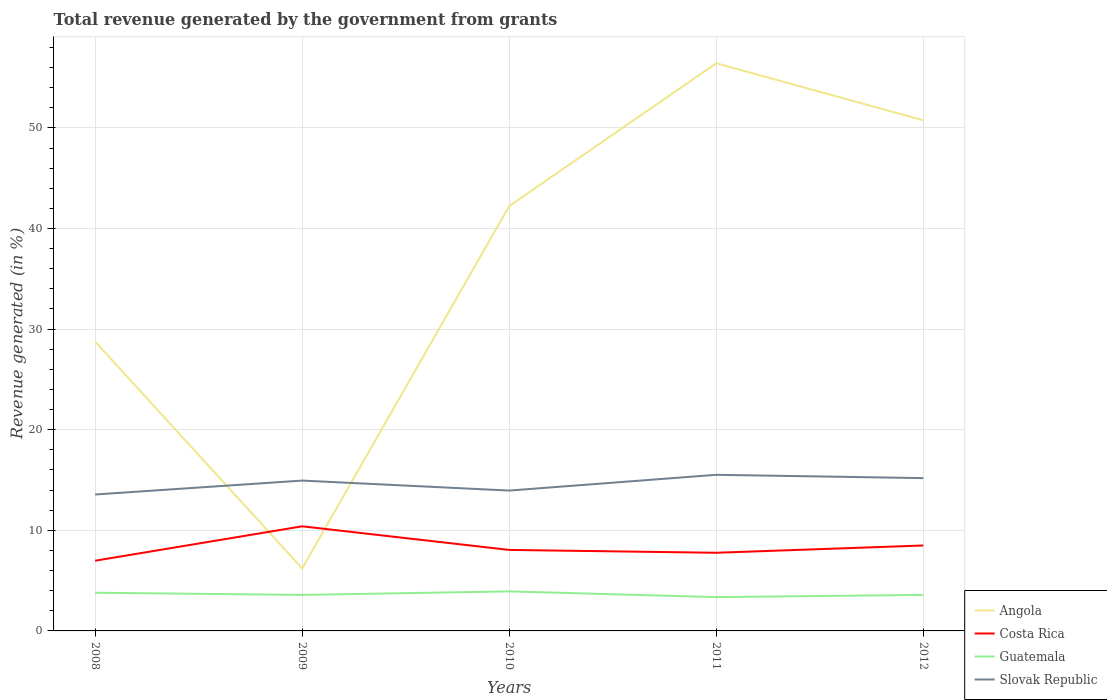How many different coloured lines are there?
Give a very brief answer. 4. Across all years, what is the maximum total revenue generated in Costa Rica?
Offer a terse response. 6.98. What is the total total revenue generated in Slovak Republic in the graph?
Give a very brief answer. -1.24. What is the difference between the highest and the second highest total revenue generated in Angola?
Make the answer very short. 50.21. What is the difference between the highest and the lowest total revenue generated in Angola?
Provide a short and direct response. 3. Is the total revenue generated in Guatemala strictly greater than the total revenue generated in Costa Rica over the years?
Keep it short and to the point. Yes. How many lines are there?
Provide a short and direct response. 4. Does the graph contain any zero values?
Offer a terse response. No. How are the legend labels stacked?
Offer a very short reply. Vertical. What is the title of the graph?
Your answer should be compact. Total revenue generated by the government from grants. What is the label or title of the X-axis?
Your response must be concise. Years. What is the label or title of the Y-axis?
Make the answer very short. Revenue generated (in %). What is the Revenue generated (in %) of Angola in 2008?
Ensure brevity in your answer.  28.76. What is the Revenue generated (in %) in Costa Rica in 2008?
Provide a short and direct response. 6.98. What is the Revenue generated (in %) of Guatemala in 2008?
Ensure brevity in your answer.  3.8. What is the Revenue generated (in %) of Slovak Republic in 2008?
Keep it short and to the point. 13.56. What is the Revenue generated (in %) of Angola in 2009?
Your answer should be compact. 6.22. What is the Revenue generated (in %) of Costa Rica in 2009?
Your answer should be very brief. 10.4. What is the Revenue generated (in %) in Guatemala in 2009?
Make the answer very short. 3.58. What is the Revenue generated (in %) in Slovak Republic in 2009?
Provide a succinct answer. 14.94. What is the Revenue generated (in %) of Angola in 2010?
Give a very brief answer. 42.23. What is the Revenue generated (in %) in Costa Rica in 2010?
Give a very brief answer. 8.05. What is the Revenue generated (in %) in Guatemala in 2010?
Make the answer very short. 3.93. What is the Revenue generated (in %) of Slovak Republic in 2010?
Provide a succinct answer. 13.95. What is the Revenue generated (in %) in Angola in 2011?
Provide a succinct answer. 56.43. What is the Revenue generated (in %) in Costa Rica in 2011?
Provide a succinct answer. 7.77. What is the Revenue generated (in %) in Guatemala in 2011?
Provide a succinct answer. 3.36. What is the Revenue generated (in %) in Slovak Republic in 2011?
Your answer should be compact. 15.52. What is the Revenue generated (in %) in Angola in 2012?
Your response must be concise. 50.76. What is the Revenue generated (in %) of Costa Rica in 2012?
Provide a succinct answer. 8.49. What is the Revenue generated (in %) of Guatemala in 2012?
Provide a short and direct response. 3.58. What is the Revenue generated (in %) in Slovak Republic in 2012?
Provide a succinct answer. 15.19. Across all years, what is the maximum Revenue generated (in %) of Angola?
Make the answer very short. 56.43. Across all years, what is the maximum Revenue generated (in %) in Costa Rica?
Provide a succinct answer. 10.4. Across all years, what is the maximum Revenue generated (in %) of Guatemala?
Provide a short and direct response. 3.93. Across all years, what is the maximum Revenue generated (in %) of Slovak Republic?
Keep it short and to the point. 15.52. Across all years, what is the minimum Revenue generated (in %) of Angola?
Provide a short and direct response. 6.22. Across all years, what is the minimum Revenue generated (in %) of Costa Rica?
Provide a short and direct response. 6.98. Across all years, what is the minimum Revenue generated (in %) in Guatemala?
Your response must be concise. 3.36. Across all years, what is the minimum Revenue generated (in %) in Slovak Republic?
Your answer should be compact. 13.56. What is the total Revenue generated (in %) in Angola in the graph?
Offer a very short reply. 184.39. What is the total Revenue generated (in %) in Costa Rica in the graph?
Keep it short and to the point. 41.69. What is the total Revenue generated (in %) of Guatemala in the graph?
Make the answer very short. 18.25. What is the total Revenue generated (in %) of Slovak Republic in the graph?
Keep it short and to the point. 73.17. What is the difference between the Revenue generated (in %) of Angola in 2008 and that in 2009?
Offer a terse response. 22.55. What is the difference between the Revenue generated (in %) of Costa Rica in 2008 and that in 2009?
Your response must be concise. -3.42. What is the difference between the Revenue generated (in %) of Guatemala in 2008 and that in 2009?
Provide a succinct answer. 0.22. What is the difference between the Revenue generated (in %) of Slovak Republic in 2008 and that in 2009?
Provide a short and direct response. -1.38. What is the difference between the Revenue generated (in %) in Angola in 2008 and that in 2010?
Provide a short and direct response. -13.47. What is the difference between the Revenue generated (in %) of Costa Rica in 2008 and that in 2010?
Keep it short and to the point. -1.07. What is the difference between the Revenue generated (in %) of Guatemala in 2008 and that in 2010?
Offer a very short reply. -0.13. What is the difference between the Revenue generated (in %) of Slovak Republic in 2008 and that in 2010?
Provide a short and direct response. -0.39. What is the difference between the Revenue generated (in %) of Angola in 2008 and that in 2011?
Keep it short and to the point. -27.66. What is the difference between the Revenue generated (in %) of Costa Rica in 2008 and that in 2011?
Give a very brief answer. -0.79. What is the difference between the Revenue generated (in %) in Guatemala in 2008 and that in 2011?
Provide a succinct answer. 0.44. What is the difference between the Revenue generated (in %) in Slovak Republic in 2008 and that in 2011?
Ensure brevity in your answer.  -1.96. What is the difference between the Revenue generated (in %) of Angola in 2008 and that in 2012?
Ensure brevity in your answer.  -21.99. What is the difference between the Revenue generated (in %) in Costa Rica in 2008 and that in 2012?
Keep it short and to the point. -1.51. What is the difference between the Revenue generated (in %) in Guatemala in 2008 and that in 2012?
Make the answer very short. 0.22. What is the difference between the Revenue generated (in %) of Slovak Republic in 2008 and that in 2012?
Offer a terse response. -1.63. What is the difference between the Revenue generated (in %) in Angola in 2009 and that in 2010?
Your answer should be very brief. -36.02. What is the difference between the Revenue generated (in %) in Costa Rica in 2009 and that in 2010?
Ensure brevity in your answer.  2.35. What is the difference between the Revenue generated (in %) in Guatemala in 2009 and that in 2010?
Keep it short and to the point. -0.35. What is the difference between the Revenue generated (in %) of Angola in 2009 and that in 2011?
Make the answer very short. -50.21. What is the difference between the Revenue generated (in %) in Costa Rica in 2009 and that in 2011?
Your answer should be very brief. 2.63. What is the difference between the Revenue generated (in %) in Guatemala in 2009 and that in 2011?
Your answer should be very brief. 0.22. What is the difference between the Revenue generated (in %) of Slovak Republic in 2009 and that in 2011?
Your response must be concise. -0.57. What is the difference between the Revenue generated (in %) of Angola in 2009 and that in 2012?
Your response must be concise. -44.54. What is the difference between the Revenue generated (in %) of Costa Rica in 2009 and that in 2012?
Your answer should be very brief. 1.91. What is the difference between the Revenue generated (in %) in Guatemala in 2009 and that in 2012?
Keep it short and to the point. -0. What is the difference between the Revenue generated (in %) in Slovak Republic in 2009 and that in 2012?
Offer a very short reply. -0.25. What is the difference between the Revenue generated (in %) of Angola in 2010 and that in 2011?
Provide a short and direct response. -14.2. What is the difference between the Revenue generated (in %) of Costa Rica in 2010 and that in 2011?
Offer a terse response. 0.28. What is the difference between the Revenue generated (in %) of Guatemala in 2010 and that in 2011?
Offer a terse response. 0.57. What is the difference between the Revenue generated (in %) in Slovak Republic in 2010 and that in 2011?
Your response must be concise. -1.57. What is the difference between the Revenue generated (in %) in Angola in 2010 and that in 2012?
Your answer should be very brief. -8.53. What is the difference between the Revenue generated (in %) of Costa Rica in 2010 and that in 2012?
Keep it short and to the point. -0.44. What is the difference between the Revenue generated (in %) in Guatemala in 2010 and that in 2012?
Provide a succinct answer. 0.35. What is the difference between the Revenue generated (in %) of Slovak Republic in 2010 and that in 2012?
Your answer should be very brief. -1.24. What is the difference between the Revenue generated (in %) in Angola in 2011 and that in 2012?
Your answer should be very brief. 5.67. What is the difference between the Revenue generated (in %) of Costa Rica in 2011 and that in 2012?
Keep it short and to the point. -0.72. What is the difference between the Revenue generated (in %) in Guatemala in 2011 and that in 2012?
Your answer should be compact. -0.22. What is the difference between the Revenue generated (in %) in Slovak Republic in 2011 and that in 2012?
Your answer should be compact. 0.33. What is the difference between the Revenue generated (in %) of Angola in 2008 and the Revenue generated (in %) of Costa Rica in 2009?
Give a very brief answer. 18.37. What is the difference between the Revenue generated (in %) of Angola in 2008 and the Revenue generated (in %) of Guatemala in 2009?
Your answer should be compact. 25.18. What is the difference between the Revenue generated (in %) of Angola in 2008 and the Revenue generated (in %) of Slovak Republic in 2009?
Offer a very short reply. 13.82. What is the difference between the Revenue generated (in %) of Costa Rica in 2008 and the Revenue generated (in %) of Guatemala in 2009?
Keep it short and to the point. 3.4. What is the difference between the Revenue generated (in %) of Costa Rica in 2008 and the Revenue generated (in %) of Slovak Republic in 2009?
Give a very brief answer. -7.97. What is the difference between the Revenue generated (in %) in Guatemala in 2008 and the Revenue generated (in %) in Slovak Republic in 2009?
Give a very brief answer. -11.15. What is the difference between the Revenue generated (in %) in Angola in 2008 and the Revenue generated (in %) in Costa Rica in 2010?
Ensure brevity in your answer.  20.71. What is the difference between the Revenue generated (in %) in Angola in 2008 and the Revenue generated (in %) in Guatemala in 2010?
Make the answer very short. 24.84. What is the difference between the Revenue generated (in %) of Angola in 2008 and the Revenue generated (in %) of Slovak Republic in 2010?
Your answer should be very brief. 14.81. What is the difference between the Revenue generated (in %) in Costa Rica in 2008 and the Revenue generated (in %) in Guatemala in 2010?
Your answer should be compact. 3.05. What is the difference between the Revenue generated (in %) in Costa Rica in 2008 and the Revenue generated (in %) in Slovak Republic in 2010?
Offer a very short reply. -6.97. What is the difference between the Revenue generated (in %) of Guatemala in 2008 and the Revenue generated (in %) of Slovak Republic in 2010?
Make the answer very short. -10.15. What is the difference between the Revenue generated (in %) in Angola in 2008 and the Revenue generated (in %) in Costa Rica in 2011?
Make the answer very short. 21. What is the difference between the Revenue generated (in %) of Angola in 2008 and the Revenue generated (in %) of Guatemala in 2011?
Your answer should be compact. 25.4. What is the difference between the Revenue generated (in %) of Angola in 2008 and the Revenue generated (in %) of Slovak Republic in 2011?
Your response must be concise. 13.25. What is the difference between the Revenue generated (in %) of Costa Rica in 2008 and the Revenue generated (in %) of Guatemala in 2011?
Give a very brief answer. 3.62. What is the difference between the Revenue generated (in %) of Costa Rica in 2008 and the Revenue generated (in %) of Slovak Republic in 2011?
Your response must be concise. -8.54. What is the difference between the Revenue generated (in %) of Guatemala in 2008 and the Revenue generated (in %) of Slovak Republic in 2011?
Provide a succinct answer. -11.72. What is the difference between the Revenue generated (in %) of Angola in 2008 and the Revenue generated (in %) of Costa Rica in 2012?
Your answer should be compact. 20.27. What is the difference between the Revenue generated (in %) of Angola in 2008 and the Revenue generated (in %) of Guatemala in 2012?
Keep it short and to the point. 25.18. What is the difference between the Revenue generated (in %) of Angola in 2008 and the Revenue generated (in %) of Slovak Republic in 2012?
Provide a short and direct response. 13.57. What is the difference between the Revenue generated (in %) in Costa Rica in 2008 and the Revenue generated (in %) in Guatemala in 2012?
Your response must be concise. 3.4. What is the difference between the Revenue generated (in %) in Costa Rica in 2008 and the Revenue generated (in %) in Slovak Republic in 2012?
Offer a very short reply. -8.21. What is the difference between the Revenue generated (in %) of Guatemala in 2008 and the Revenue generated (in %) of Slovak Republic in 2012?
Your answer should be compact. -11.39. What is the difference between the Revenue generated (in %) of Angola in 2009 and the Revenue generated (in %) of Costa Rica in 2010?
Offer a terse response. -1.84. What is the difference between the Revenue generated (in %) of Angola in 2009 and the Revenue generated (in %) of Guatemala in 2010?
Your response must be concise. 2.29. What is the difference between the Revenue generated (in %) of Angola in 2009 and the Revenue generated (in %) of Slovak Republic in 2010?
Keep it short and to the point. -7.74. What is the difference between the Revenue generated (in %) of Costa Rica in 2009 and the Revenue generated (in %) of Guatemala in 2010?
Offer a very short reply. 6.47. What is the difference between the Revenue generated (in %) in Costa Rica in 2009 and the Revenue generated (in %) in Slovak Republic in 2010?
Ensure brevity in your answer.  -3.55. What is the difference between the Revenue generated (in %) in Guatemala in 2009 and the Revenue generated (in %) in Slovak Republic in 2010?
Give a very brief answer. -10.37. What is the difference between the Revenue generated (in %) of Angola in 2009 and the Revenue generated (in %) of Costa Rica in 2011?
Provide a short and direct response. -1.55. What is the difference between the Revenue generated (in %) of Angola in 2009 and the Revenue generated (in %) of Guatemala in 2011?
Provide a short and direct response. 2.85. What is the difference between the Revenue generated (in %) of Angola in 2009 and the Revenue generated (in %) of Slovak Republic in 2011?
Make the answer very short. -9.3. What is the difference between the Revenue generated (in %) of Costa Rica in 2009 and the Revenue generated (in %) of Guatemala in 2011?
Offer a terse response. 7.04. What is the difference between the Revenue generated (in %) in Costa Rica in 2009 and the Revenue generated (in %) in Slovak Republic in 2011?
Ensure brevity in your answer.  -5.12. What is the difference between the Revenue generated (in %) in Guatemala in 2009 and the Revenue generated (in %) in Slovak Republic in 2011?
Your response must be concise. -11.94. What is the difference between the Revenue generated (in %) of Angola in 2009 and the Revenue generated (in %) of Costa Rica in 2012?
Your response must be concise. -2.28. What is the difference between the Revenue generated (in %) of Angola in 2009 and the Revenue generated (in %) of Guatemala in 2012?
Provide a short and direct response. 2.63. What is the difference between the Revenue generated (in %) of Angola in 2009 and the Revenue generated (in %) of Slovak Republic in 2012?
Your answer should be very brief. -8.97. What is the difference between the Revenue generated (in %) of Costa Rica in 2009 and the Revenue generated (in %) of Guatemala in 2012?
Ensure brevity in your answer.  6.82. What is the difference between the Revenue generated (in %) in Costa Rica in 2009 and the Revenue generated (in %) in Slovak Republic in 2012?
Offer a very short reply. -4.79. What is the difference between the Revenue generated (in %) of Guatemala in 2009 and the Revenue generated (in %) of Slovak Republic in 2012?
Make the answer very short. -11.61. What is the difference between the Revenue generated (in %) of Angola in 2010 and the Revenue generated (in %) of Costa Rica in 2011?
Provide a short and direct response. 34.46. What is the difference between the Revenue generated (in %) of Angola in 2010 and the Revenue generated (in %) of Guatemala in 2011?
Provide a short and direct response. 38.87. What is the difference between the Revenue generated (in %) of Angola in 2010 and the Revenue generated (in %) of Slovak Republic in 2011?
Your response must be concise. 26.71. What is the difference between the Revenue generated (in %) in Costa Rica in 2010 and the Revenue generated (in %) in Guatemala in 2011?
Ensure brevity in your answer.  4.69. What is the difference between the Revenue generated (in %) of Costa Rica in 2010 and the Revenue generated (in %) of Slovak Republic in 2011?
Keep it short and to the point. -7.47. What is the difference between the Revenue generated (in %) in Guatemala in 2010 and the Revenue generated (in %) in Slovak Republic in 2011?
Offer a terse response. -11.59. What is the difference between the Revenue generated (in %) of Angola in 2010 and the Revenue generated (in %) of Costa Rica in 2012?
Your answer should be compact. 33.74. What is the difference between the Revenue generated (in %) of Angola in 2010 and the Revenue generated (in %) of Guatemala in 2012?
Give a very brief answer. 38.65. What is the difference between the Revenue generated (in %) of Angola in 2010 and the Revenue generated (in %) of Slovak Republic in 2012?
Provide a succinct answer. 27.04. What is the difference between the Revenue generated (in %) in Costa Rica in 2010 and the Revenue generated (in %) in Guatemala in 2012?
Provide a succinct answer. 4.47. What is the difference between the Revenue generated (in %) of Costa Rica in 2010 and the Revenue generated (in %) of Slovak Republic in 2012?
Your response must be concise. -7.14. What is the difference between the Revenue generated (in %) in Guatemala in 2010 and the Revenue generated (in %) in Slovak Republic in 2012?
Make the answer very short. -11.26. What is the difference between the Revenue generated (in %) in Angola in 2011 and the Revenue generated (in %) in Costa Rica in 2012?
Your answer should be very brief. 47.93. What is the difference between the Revenue generated (in %) in Angola in 2011 and the Revenue generated (in %) in Guatemala in 2012?
Make the answer very short. 52.85. What is the difference between the Revenue generated (in %) in Angola in 2011 and the Revenue generated (in %) in Slovak Republic in 2012?
Keep it short and to the point. 41.24. What is the difference between the Revenue generated (in %) of Costa Rica in 2011 and the Revenue generated (in %) of Guatemala in 2012?
Make the answer very short. 4.19. What is the difference between the Revenue generated (in %) of Costa Rica in 2011 and the Revenue generated (in %) of Slovak Republic in 2012?
Your answer should be very brief. -7.42. What is the difference between the Revenue generated (in %) of Guatemala in 2011 and the Revenue generated (in %) of Slovak Republic in 2012?
Your answer should be compact. -11.83. What is the average Revenue generated (in %) in Angola per year?
Provide a succinct answer. 36.88. What is the average Revenue generated (in %) in Costa Rica per year?
Keep it short and to the point. 8.34. What is the average Revenue generated (in %) in Guatemala per year?
Offer a terse response. 3.65. What is the average Revenue generated (in %) in Slovak Republic per year?
Offer a terse response. 14.63. In the year 2008, what is the difference between the Revenue generated (in %) of Angola and Revenue generated (in %) of Costa Rica?
Keep it short and to the point. 21.79. In the year 2008, what is the difference between the Revenue generated (in %) in Angola and Revenue generated (in %) in Guatemala?
Ensure brevity in your answer.  24.97. In the year 2008, what is the difference between the Revenue generated (in %) of Angola and Revenue generated (in %) of Slovak Republic?
Your response must be concise. 15.2. In the year 2008, what is the difference between the Revenue generated (in %) of Costa Rica and Revenue generated (in %) of Guatemala?
Provide a succinct answer. 3.18. In the year 2008, what is the difference between the Revenue generated (in %) of Costa Rica and Revenue generated (in %) of Slovak Republic?
Your answer should be compact. -6.58. In the year 2008, what is the difference between the Revenue generated (in %) of Guatemala and Revenue generated (in %) of Slovak Republic?
Provide a short and direct response. -9.76. In the year 2009, what is the difference between the Revenue generated (in %) of Angola and Revenue generated (in %) of Costa Rica?
Make the answer very short. -4.18. In the year 2009, what is the difference between the Revenue generated (in %) in Angola and Revenue generated (in %) in Guatemala?
Your response must be concise. 2.64. In the year 2009, what is the difference between the Revenue generated (in %) in Angola and Revenue generated (in %) in Slovak Republic?
Give a very brief answer. -8.73. In the year 2009, what is the difference between the Revenue generated (in %) in Costa Rica and Revenue generated (in %) in Guatemala?
Offer a very short reply. 6.82. In the year 2009, what is the difference between the Revenue generated (in %) in Costa Rica and Revenue generated (in %) in Slovak Republic?
Your answer should be compact. -4.55. In the year 2009, what is the difference between the Revenue generated (in %) of Guatemala and Revenue generated (in %) of Slovak Republic?
Provide a short and direct response. -11.36. In the year 2010, what is the difference between the Revenue generated (in %) of Angola and Revenue generated (in %) of Costa Rica?
Provide a succinct answer. 34.18. In the year 2010, what is the difference between the Revenue generated (in %) in Angola and Revenue generated (in %) in Guatemala?
Your answer should be compact. 38.3. In the year 2010, what is the difference between the Revenue generated (in %) of Angola and Revenue generated (in %) of Slovak Republic?
Give a very brief answer. 28.28. In the year 2010, what is the difference between the Revenue generated (in %) of Costa Rica and Revenue generated (in %) of Guatemala?
Make the answer very short. 4.12. In the year 2010, what is the difference between the Revenue generated (in %) in Costa Rica and Revenue generated (in %) in Slovak Republic?
Give a very brief answer. -5.9. In the year 2010, what is the difference between the Revenue generated (in %) in Guatemala and Revenue generated (in %) in Slovak Republic?
Ensure brevity in your answer.  -10.02. In the year 2011, what is the difference between the Revenue generated (in %) of Angola and Revenue generated (in %) of Costa Rica?
Your answer should be very brief. 48.66. In the year 2011, what is the difference between the Revenue generated (in %) of Angola and Revenue generated (in %) of Guatemala?
Make the answer very short. 53.07. In the year 2011, what is the difference between the Revenue generated (in %) in Angola and Revenue generated (in %) in Slovak Republic?
Ensure brevity in your answer.  40.91. In the year 2011, what is the difference between the Revenue generated (in %) of Costa Rica and Revenue generated (in %) of Guatemala?
Keep it short and to the point. 4.41. In the year 2011, what is the difference between the Revenue generated (in %) in Costa Rica and Revenue generated (in %) in Slovak Republic?
Your response must be concise. -7.75. In the year 2011, what is the difference between the Revenue generated (in %) of Guatemala and Revenue generated (in %) of Slovak Republic?
Provide a short and direct response. -12.16. In the year 2012, what is the difference between the Revenue generated (in %) in Angola and Revenue generated (in %) in Costa Rica?
Your answer should be compact. 42.26. In the year 2012, what is the difference between the Revenue generated (in %) in Angola and Revenue generated (in %) in Guatemala?
Give a very brief answer. 47.18. In the year 2012, what is the difference between the Revenue generated (in %) of Angola and Revenue generated (in %) of Slovak Republic?
Your answer should be compact. 35.57. In the year 2012, what is the difference between the Revenue generated (in %) of Costa Rica and Revenue generated (in %) of Guatemala?
Provide a short and direct response. 4.91. In the year 2012, what is the difference between the Revenue generated (in %) in Costa Rica and Revenue generated (in %) in Slovak Republic?
Offer a terse response. -6.7. In the year 2012, what is the difference between the Revenue generated (in %) in Guatemala and Revenue generated (in %) in Slovak Republic?
Your answer should be very brief. -11.61. What is the ratio of the Revenue generated (in %) of Angola in 2008 to that in 2009?
Your answer should be very brief. 4.63. What is the ratio of the Revenue generated (in %) of Costa Rica in 2008 to that in 2009?
Ensure brevity in your answer.  0.67. What is the ratio of the Revenue generated (in %) in Guatemala in 2008 to that in 2009?
Your answer should be compact. 1.06. What is the ratio of the Revenue generated (in %) in Slovak Republic in 2008 to that in 2009?
Offer a terse response. 0.91. What is the ratio of the Revenue generated (in %) in Angola in 2008 to that in 2010?
Give a very brief answer. 0.68. What is the ratio of the Revenue generated (in %) in Costa Rica in 2008 to that in 2010?
Your answer should be compact. 0.87. What is the ratio of the Revenue generated (in %) of Guatemala in 2008 to that in 2010?
Your answer should be very brief. 0.97. What is the ratio of the Revenue generated (in %) in Angola in 2008 to that in 2011?
Offer a terse response. 0.51. What is the ratio of the Revenue generated (in %) in Costa Rica in 2008 to that in 2011?
Keep it short and to the point. 0.9. What is the ratio of the Revenue generated (in %) of Guatemala in 2008 to that in 2011?
Your response must be concise. 1.13. What is the ratio of the Revenue generated (in %) in Slovak Republic in 2008 to that in 2011?
Offer a terse response. 0.87. What is the ratio of the Revenue generated (in %) in Angola in 2008 to that in 2012?
Offer a very short reply. 0.57. What is the ratio of the Revenue generated (in %) of Costa Rica in 2008 to that in 2012?
Keep it short and to the point. 0.82. What is the ratio of the Revenue generated (in %) of Guatemala in 2008 to that in 2012?
Keep it short and to the point. 1.06. What is the ratio of the Revenue generated (in %) of Slovak Republic in 2008 to that in 2012?
Provide a succinct answer. 0.89. What is the ratio of the Revenue generated (in %) in Angola in 2009 to that in 2010?
Offer a terse response. 0.15. What is the ratio of the Revenue generated (in %) of Costa Rica in 2009 to that in 2010?
Ensure brevity in your answer.  1.29. What is the ratio of the Revenue generated (in %) in Guatemala in 2009 to that in 2010?
Give a very brief answer. 0.91. What is the ratio of the Revenue generated (in %) of Slovak Republic in 2009 to that in 2010?
Ensure brevity in your answer.  1.07. What is the ratio of the Revenue generated (in %) of Angola in 2009 to that in 2011?
Keep it short and to the point. 0.11. What is the ratio of the Revenue generated (in %) of Costa Rica in 2009 to that in 2011?
Keep it short and to the point. 1.34. What is the ratio of the Revenue generated (in %) in Guatemala in 2009 to that in 2011?
Provide a succinct answer. 1.07. What is the ratio of the Revenue generated (in %) in Slovak Republic in 2009 to that in 2011?
Give a very brief answer. 0.96. What is the ratio of the Revenue generated (in %) of Angola in 2009 to that in 2012?
Keep it short and to the point. 0.12. What is the ratio of the Revenue generated (in %) of Costa Rica in 2009 to that in 2012?
Give a very brief answer. 1.22. What is the ratio of the Revenue generated (in %) of Slovak Republic in 2009 to that in 2012?
Ensure brevity in your answer.  0.98. What is the ratio of the Revenue generated (in %) in Angola in 2010 to that in 2011?
Make the answer very short. 0.75. What is the ratio of the Revenue generated (in %) of Costa Rica in 2010 to that in 2011?
Ensure brevity in your answer.  1.04. What is the ratio of the Revenue generated (in %) in Guatemala in 2010 to that in 2011?
Give a very brief answer. 1.17. What is the ratio of the Revenue generated (in %) in Slovak Republic in 2010 to that in 2011?
Provide a succinct answer. 0.9. What is the ratio of the Revenue generated (in %) of Angola in 2010 to that in 2012?
Give a very brief answer. 0.83. What is the ratio of the Revenue generated (in %) in Costa Rica in 2010 to that in 2012?
Your answer should be very brief. 0.95. What is the ratio of the Revenue generated (in %) of Guatemala in 2010 to that in 2012?
Give a very brief answer. 1.1. What is the ratio of the Revenue generated (in %) in Slovak Republic in 2010 to that in 2012?
Your response must be concise. 0.92. What is the ratio of the Revenue generated (in %) in Angola in 2011 to that in 2012?
Ensure brevity in your answer.  1.11. What is the ratio of the Revenue generated (in %) in Costa Rica in 2011 to that in 2012?
Give a very brief answer. 0.91. What is the ratio of the Revenue generated (in %) in Guatemala in 2011 to that in 2012?
Provide a succinct answer. 0.94. What is the ratio of the Revenue generated (in %) of Slovak Republic in 2011 to that in 2012?
Offer a very short reply. 1.02. What is the difference between the highest and the second highest Revenue generated (in %) of Angola?
Offer a terse response. 5.67. What is the difference between the highest and the second highest Revenue generated (in %) of Costa Rica?
Keep it short and to the point. 1.91. What is the difference between the highest and the second highest Revenue generated (in %) in Guatemala?
Your answer should be very brief. 0.13. What is the difference between the highest and the second highest Revenue generated (in %) in Slovak Republic?
Ensure brevity in your answer.  0.33. What is the difference between the highest and the lowest Revenue generated (in %) in Angola?
Your response must be concise. 50.21. What is the difference between the highest and the lowest Revenue generated (in %) in Costa Rica?
Give a very brief answer. 3.42. What is the difference between the highest and the lowest Revenue generated (in %) in Guatemala?
Keep it short and to the point. 0.57. What is the difference between the highest and the lowest Revenue generated (in %) of Slovak Republic?
Offer a terse response. 1.96. 